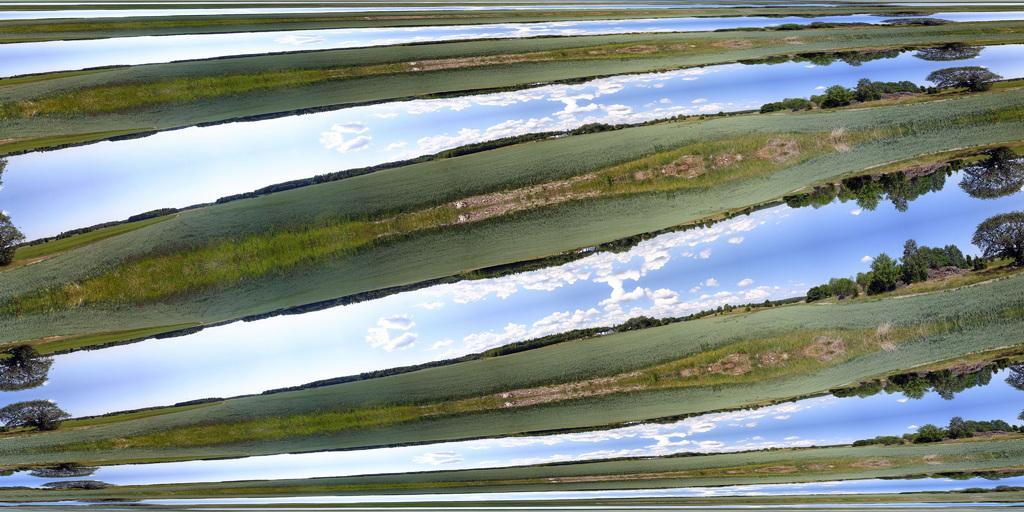Please provide a concise description of this image. This is an edited image. In this picture, we see grass and trees. We even see the sky and the clouds. This is a mirror image. 